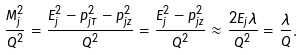Convert formula to latex. <formula><loc_0><loc_0><loc_500><loc_500>\frac { M _ { j } ^ { 2 } } { Q ^ { 2 } } = \frac { E _ { j } ^ { 2 } - p _ { j T } ^ { 2 } - p _ { j z } ^ { 2 } } { Q ^ { 2 } } = \frac { E _ { j } ^ { 2 } - p _ { j z } ^ { 2 } } { Q ^ { 2 } } \approx \frac { 2 E _ { j } \lambda } { Q ^ { 2 } } = \frac { \lambda } { Q } .</formula> 